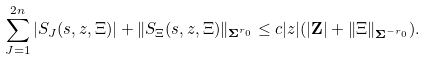Convert formula to latex. <formula><loc_0><loc_0><loc_500><loc_500>\sum _ { J = 1 } ^ { 2 n } | S _ { J } ( s , z , \Xi ) | + \| S _ { \Xi } ( s , z , \Xi ) \| _ { \mathbf \Sigma ^ { r _ { 0 } } } \leq c | z | ( | \mathbf Z | + \| \Xi \| _ { \mathbf \Sigma ^ { - r _ { 0 } } } ) .</formula> 